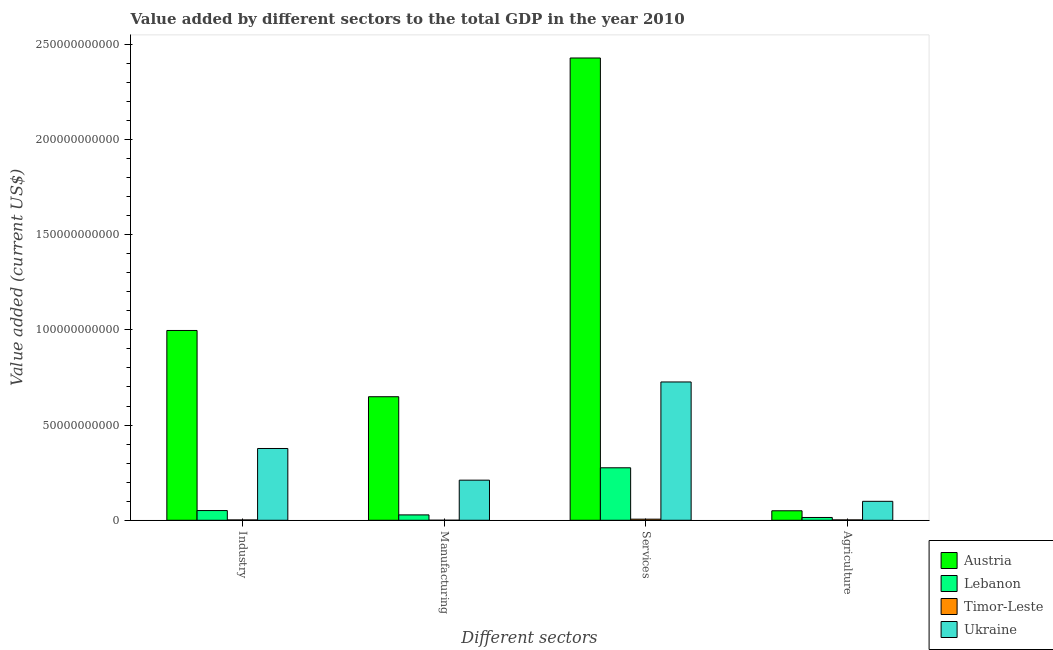How many different coloured bars are there?
Your response must be concise. 4. Are the number of bars per tick equal to the number of legend labels?
Offer a very short reply. Yes. How many bars are there on the 1st tick from the left?
Your answer should be compact. 4. What is the label of the 3rd group of bars from the left?
Keep it short and to the point. Services. Across all countries, what is the maximum value added by manufacturing sector?
Make the answer very short. 6.49e+1. Across all countries, what is the minimum value added by services sector?
Your answer should be compact. 5.83e+08. In which country was the value added by industrial sector maximum?
Keep it short and to the point. Austria. In which country was the value added by agricultural sector minimum?
Offer a very short reply. Timor-Leste. What is the total value added by manufacturing sector in the graph?
Keep it short and to the point. 8.88e+1. What is the difference between the value added by manufacturing sector in Ukraine and that in Lebanon?
Provide a succinct answer. 1.82e+1. What is the difference between the value added by manufacturing sector in Lebanon and the value added by industrial sector in Timor-Leste?
Offer a very short reply. 2.65e+09. What is the average value added by industrial sector per country?
Provide a succinct answer. 3.57e+1. What is the difference between the value added by manufacturing sector and value added by services sector in Timor-Leste?
Offer a very short reply. -5.73e+08. In how many countries, is the value added by agricultural sector greater than 150000000000 US$?
Keep it short and to the point. 0. What is the ratio of the value added by services sector in Timor-Leste to that in Lebanon?
Give a very brief answer. 0.02. Is the value added by agricultural sector in Ukraine less than that in Lebanon?
Provide a short and direct response. No. What is the difference between the highest and the second highest value added by agricultural sector?
Keep it short and to the point. 4.97e+09. What is the difference between the highest and the lowest value added by services sector?
Give a very brief answer. 2.42e+11. Is the sum of the value added by industrial sector in Ukraine and Lebanon greater than the maximum value added by manufacturing sector across all countries?
Offer a terse response. No. What does the 3rd bar from the left in Manufacturing represents?
Keep it short and to the point. Timor-Leste. What does the 3rd bar from the right in Manufacturing represents?
Make the answer very short. Lebanon. Is it the case that in every country, the sum of the value added by industrial sector and value added by manufacturing sector is greater than the value added by services sector?
Offer a terse response. No. Are all the bars in the graph horizontal?
Give a very brief answer. No. How many countries are there in the graph?
Provide a succinct answer. 4. Does the graph contain any zero values?
Provide a short and direct response. No. Does the graph contain grids?
Give a very brief answer. No. Where does the legend appear in the graph?
Provide a short and direct response. Bottom right. How many legend labels are there?
Provide a short and direct response. 4. How are the legend labels stacked?
Offer a very short reply. Vertical. What is the title of the graph?
Give a very brief answer. Value added by different sectors to the total GDP in the year 2010. What is the label or title of the X-axis?
Offer a very short reply. Different sectors. What is the label or title of the Y-axis?
Your answer should be very brief. Value added (current US$). What is the Value added (current US$) of Austria in Industry?
Provide a short and direct response. 9.97e+1. What is the Value added (current US$) in Lebanon in Industry?
Ensure brevity in your answer.  5.10e+09. What is the Value added (current US$) in Timor-Leste in Industry?
Provide a succinct answer. 1.66e+08. What is the Value added (current US$) of Ukraine in Industry?
Ensure brevity in your answer.  3.77e+1. What is the Value added (current US$) in Austria in Manufacturing?
Ensure brevity in your answer.  6.49e+1. What is the Value added (current US$) of Lebanon in Manufacturing?
Offer a very short reply. 2.82e+09. What is the Value added (current US$) in Timor-Leste in Manufacturing?
Provide a short and direct response. 1.00e+07. What is the Value added (current US$) in Ukraine in Manufacturing?
Your response must be concise. 2.11e+1. What is the Value added (current US$) in Austria in Services?
Your answer should be very brief. 2.43e+11. What is the Value added (current US$) in Lebanon in Services?
Ensure brevity in your answer.  2.76e+1. What is the Value added (current US$) of Timor-Leste in Services?
Provide a short and direct response. 5.83e+08. What is the Value added (current US$) of Ukraine in Services?
Keep it short and to the point. 7.26e+1. What is the Value added (current US$) in Austria in Agriculture?
Offer a terse response. 4.98e+09. What is the Value added (current US$) in Lebanon in Agriculture?
Ensure brevity in your answer.  1.46e+09. What is the Value added (current US$) in Timor-Leste in Agriculture?
Provide a succinct answer. 1.91e+08. What is the Value added (current US$) of Ukraine in Agriculture?
Keep it short and to the point. 9.95e+09. Across all Different sectors, what is the maximum Value added (current US$) of Austria?
Your answer should be very brief. 2.43e+11. Across all Different sectors, what is the maximum Value added (current US$) of Lebanon?
Keep it short and to the point. 2.76e+1. Across all Different sectors, what is the maximum Value added (current US$) of Timor-Leste?
Provide a succinct answer. 5.83e+08. Across all Different sectors, what is the maximum Value added (current US$) of Ukraine?
Your answer should be very brief. 7.26e+1. Across all Different sectors, what is the minimum Value added (current US$) in Austria?
Your answer should be very brief. 4.98e+09. Across all Different sectors, what is the minimum Value added (current US$) in Lebanon?
Your answer should be very brief. 1.46e+09. Across all Different sectors, what is the minimum Value added (current US$) of Timor-Leste?
Offer a terse response. 1.00e+07. Across all Different sectors, what is the minimum Value added (current US$) of Ukraine?
Give a very brief answer. 9.95e+09. What is the total Value added (current US$) of Austria in the graph?
Your answer should be compact. 4.12e+11. What is the total Value added (current US$) in Lebanon in the graph?
Your answer should be very brief. 3.69e+1. What is the total Value added (current US$) of Timor-Leste in the graph?
Your answer should be very brief. 9.50e+08. What is the total Value added (current US$) in Ukraine in the graph?
Your response must be concise. 1.41e+11. What is the difference between the Value added (current US$) in Austria in Industry and that in Manufacturing?
Offer a terse response. 3.48e+1. What is the difference between the Value added (current US$) of Lebanon in Industry and that in Manufacturing?
Provide a short and direct response. 2.28e+09. What is the difference between the Value added (current US$) of Timor-Leste in Industry and that in Manufacturing?
Offer a very short reply. 1.56e+08. What is the difference between the Value added (current US$) of Ukraine in Industry and that in Manufacturing?
Offer a very short reply. 1.66e+1. What is the difference between the Value added (current US$) in Austria in Industry and that in Services?
Ensure brevity in your answer.  -1.43e+11. What is the difference between the Value added (current US$) in Lebanon in Industry and that in Services?
Your answer should be very brief. -2.25e+1. What is the difference between the Value added (current US$) of Timor-Leste in Industry and that in Services?
Make the answer very short. -4.17e+08. What is the difference between the Value added (current US$) in Ukraine in Industry and that in Services?
Your answer should be very brief. -3.49e+1. What is the difference between the Value added (current US$) of Austria in Industry and that in Agriculture?
Provide a succinct answer. 9.47e+1. What is the difference between the Value added (current US$) of Lebanon in Industry and that in Agriculture?
Provide a succinct answer. 3.63e+09. What is the difference between the Value added (current US$) in Timor-Leste in Industry and that in Agriculture?
Your answer should be very brief. -2.50e+07. What is the difference between the Value added (current US$) of Ukraine in Industry and that in Agriculture?
Your answer should be very brief. 2.77e+1. What is the difference between the Value added (current US$) of Austria in Manufacturing and that in Services?
Make the answer very short. -1.78e+11. What is the difference between the Value added (current US$) of Lebanon in Manufacturing and that in Services?
Provide a succinct answer. -2.47e+1. What is the difference between the Value added (current US$) of Timor-Leste in Manufacturing and that in Services?
Provide a succinct answer. -5.73e+08. What is the difference between the Value added (current US$) in Ukraine in Manufacturing and that in Services?
Your answer should be compact. -5.16e+1. What is the difference between the Value added (current US$) of Austria in Manufacturing and that in Agriculture?
Make the answer very short. 5.99e+1. What is the difference between the Value added (current US$) of Lebanon in Manufacturing and that in Agriculture?
Offer a terse response. 1.36e+09. What is the difference between the Value added (current US$) of Timor-Leste in Manufacturing and that in Agriculture?
Ensure brevity in your answer.  -1.81e+08. What is the difference between the Value added (current US$) of Ukraine in Manufacturing and that in Agriculture?
Make the answer very short. 1.11e+1. What is the difference between the Value added (current US$) in Austria in Services and that in Agriculture?
Your response must be concise. 2.38e+11. What is the difference between the Value added (current US$) of Lebanon in Services and that in Agriculture?
Your response must be concise. 2.61e+1. What is the difference between the Value added (current US$) in Timor-Leste in Services and that in Agriculture?
Offer a terse response. 3.92e+08. What is the difference between the Value added (current US$) in Ukraine in Services and that in Agriculture?
Keep it short and to the point. 6.27e+1. What is the difference between the Value added (current US$) in Austria in Industry and the Value added (current US$) in Lebanon in Manufacturing?
Your response must be concise. 9.69e+1. What is the difference between the Value added (current US$) in Austria in Industry and the Value added (current US$) in Timor-Leste in Manufacturing?
Provide a short and direct response. 9.97e+1. What is the difference between the Value added (current US$) of Austria in Industry and the Value added (current US$) of Ukraine in Manufacturing?
Your answer should be very brief. 7.86e+1. What is the difference between the Value added (current US$) of Lebanon in Industry and the Value added (current US$) of Timor-Leste in Manufacturing?
Offer a very short reply. 5.09e+09. What is the difference between the Value added (current US$) in Lebanon in Industry and the Value added (current US$) in Ukraine in Manufacturing?
Provide a short and direct response. -1.60e+1. What is the difference between the Value added (current US$) in Timor-Leste in Industry and the Value added (current US$) in Ukraine in Manufacturing?
Your answer should be compact. -2.09e+1. What is the difference between the Value added (current US$) of Austria in Industry and the Value added (current US$) of Lebanon in Services?
Your response must be concise. 7.21e+1. What is the difference between the Value added (current US$) of Austria in Industry and the Value added (current US$) of Timor-Leste in Services?
Your answer should be very brief. 9.91e+1. What is the difference between the Value added (current US$) in Austria in Industry and the Value added (current US$) in Ukraine in Services?
Give a very brief answer. 2.70e+1. What is the difference between the Value added (current US$) in Lebanon in Industry and the Value added (current US$) in Timor-Leste in Services?
Provide a succinct answer. 4.51e+09. What is the difference between the Value added (current US$) of Lebanon in Industry and the Value added (current US$) of Ukraine in Services?
Make the answer very short. -6.75e+1. What is the difference between the Value added (current US$) of Timor-Leste in Industry and the Value added (current US$) of Ukraine in Services?
Your response must be concise. -7.25e+1. What is the difference between the Value added (current US$) of Austria in Industry and the Value added (current US$) of Lebanon in Agriculture?
Make the answer very short. 9.82e+1. What is the difference between the Value added (current US$) of Austria in Industry and the Value added (current US$) of Timor-Leste in Agriculture?
Make the answer very short. 9.95e+1. What is the difference between the Value added (current US$) in Austria in Industry and the Value added (current US$) in Ukraine in Agriculture?
Ensure brevity in your answer.  8.97e+1. What is the difference between the Value added (current US$) of Lebanon in Industry and the Value added (current US$) of Timor-Leste in Agriculture?
Your answer should be compact. 4.91e+09. What is the difference between the Value added (current US$) in Lebanon in Industry and the Value added (current US$) in Ukraine in Agriculture?
Your answer should be compact. -4.85e+09. What is the difference between the Value added (current US$) in Timor-Leste in Industry and the Value added (current US$) in Ukraine in Agriculture?
Make the answer very short. -9.78e+09. What is the difference between the Value added (current US$) in Austria in Manufacturing and the Value added (current US$) in Lebanon in Services?
Provide a short and direct response. 3.73e+1. What is the difference between the Value added (current US$) in Austria in Manufacturing and the Value added (current US$) in Timor-Leste in Services?
Your answer should be very brief. 6.43e+1. What is the difference between the Value added (current US$) in Austria in Manufacturing and the Value added (current US$) in Ukraine in Services?
Offer a terse response. -7.76e+09. What is the difference between the Value added (current US$) in Lebanon in Manufacturing and the Value added (current US$) in Timor-Leste in Services?
Your response must be concise. 2.24e+09. What is the difference between the Value added (current US$) of Lebanon in Manufacturing and the Value added (current US$) of Ukraine in Services?
Keep it short and to the point. -6.98e+1. What is the difference between the Value added (current US$) of Timor-Leste in Manufacturing and the Value added (current US$) of Ukraine in Services?
Keep it short and to the point. -7.26e+1. What is the difference between the Value added (current US$) in Austria in Manufacturing and the Value added (current US$) in Lebanon in Agriculture?
Your answer should be very brief. 6.34e+1. What is the difference between the Value added (current US$) in Austria in Manufacturing and the Value added (current US$) in Timor-Leste in Agriculture?
Your answer should be compact. 6.47e+1. What is the difference between the Value added (current US$) in Austria in Manufacturing and the Value added (current US$) in Ukraine in Agriculture?
Your answer should be very brief. 5.49e+1. What is the difference between the Value added (current US$) in Lebanon in Manufacturing and the Value added (current US$) in Timor-Leste in Agriculture?
Provide a succinct answer. 2.63e+09. What is the difference between the Value added (current US$) of Lebanon in Manufacturing and the Value added (current US$) of Ukraine in Agriculture?
Provide a succinct answer. -7.13e+09. What is the difference between the Value added (current US$) in Timor-Leste in Manufacturing and the Value added (current US$) in Ukraine in Agriculture?
Ensure brevity in your answer.  -9.94e+09. What is the difference between the Value added (current US$) in Austria in Services and the Value added (current US$) in Lebanon in Agriculture?
Your answer should be very brief. 2.41e+11. What is the difference between the Value added (current US$) of Austria in Services and the Value added (current US$) of Timor-Leste in Agriculture?
Keep it short and to the point. 2.43e+11. What is the difference between the Value added (current US$) in Austria in Services and the Value added (current US$) in Ukraine in Agriculture?
Your response must be concise. 2.33e+11. What is the difference between the Value added (current US$) in Lebanon in Services and the Value added (current US$) in Timor-Leste in Agriculture?
Your answer should be very brief. 2.74e+1. What is the difference between the Value added (current US$) in Lebanon in Services and the Value added (current US$) in Ukraine in Agriculture?
Give a very brief answer. 1.76e+1. What is the difference between the Value added (current US$) of Timor-Leste in Services and the Value added (current US$) of Ukraine in Agriculture?
Keep it short and to the point. -9.37e+09. What is the average Value added (current US$) in Austria per Different sectors?
Your answer should be compact. 1.03e+11. What is the average Value added (current US$) in Lebanon per Different sectors?
Offer a very short reply. 9.23e+09. What is the average Value added (current US$) in Timor-Leste per Different sectors?
Offer a terse response. 2.38e+08. What is the average Value added (current US$) of Ukraine per Different sectors?
Provide a short and direct response. 3.53e+1. What is the difference between the Value added (current US$) in Austria and Value added (current US$) in Lebanon in Industry?
Your response must be concise. 9.46e+1. What is the difference between the Value added (current US$) of Austria and Value added (current US$) of Timor-Leste in Industry?
Ensure brevity in your answer.  9.95e+1. What is the difference between the Value added (current US$) in Austria and Value added (current US$) in Ukraine in Industry?
Provide a succinct answer. 6.20e+1. What is the difference between the Value added (current US$) of Lebanon and Value added (current US$) of Timor-Leste in Industry?
Provide a succinct answer. 4.93e+09. What is the difference between the Value added (current US$) of Lebanon and Value added (current US$) of Ukraine in Industry?
Your response must be concise. -3.26e+1. What is the difference between the Value added (current US$) in Timor-Leste and Value added (current US$) in Ukraine in Industry?
Give a very brief answer. -3.75e+1. What is the difference between the Value added (current US$) in Austria and Value added (current US$) in Lebanon in Manufacturing?
Keep it short and to the point. 6.21e+1. What is the difference between the Value added (current US$) in Austria and Value added (current US$) in Timor-Leste in Manufacturing?
Keep it short and to the point. 6.49e+1. What is the difference between the Value added (current US$) in Austria and Value added (current US$) in Ukraine in Manufacturing?
Offer a terse response. 4.38e+1. What is the difference between the Value added (current US$) in Lebanon and Value added (current US$) in Timor-Leste in Manufacturing?
Your answer should be compact. 2.81e+09. What is the difference between the Value added (current US$) of Lebanon and Value added (current US$) of Ukraine in Manufacturing?
Provide a short and direct response. -1.82e+1. What is the difference between the Value added (current US$) of Timor-Leste and Value added (current US$) of Ukraine in Manufacturing?
Offer a very short reply. -2.11e+1. What is the difference between the Value added (current US$) in Austria and Value added (current US$) in Lebanon in Services?
Your response must be concise. 2.15e+11. What is the difference between the Value added (current US$) of Austria and Value added (current US$) of Timor-Leste in Services?
Give a very brief answer. 2.42e+11. What is the difference between the Value added (current US$) in Austria and Value added (current US$) in Ukraine in Services?
Make the answer very short. 1.70e+11. What is the difference between the Value added (current US$) in Lebanon and Value added (current US$) in Timor-Leste in Services?
Provide a short and direct response. 2.70e+1. What is the difference between the Value added (current US$) in Lebanon and Value added (current US$) in Ukraine in Services?
Your response must be concise. -4.51e+1. What is the difference between the Value added (current US$) of Timor-Leste and Value added (current US$) of Ukraine in Services?
Your response must be concise. -7.21e+1. What is the difference between the Value added (current US$) of Austria and Value added (current US$) of Lebanon in Agriculture?
Offer a very short reply. 3.52e+09. What is the difference between the Value added (current US$) of Austria and Value added (current US$) of Timor-Leste in Agriculture?
Make the answer very short. 4.79e+09. What is the difference between the Value added (current US$) of Austria and Value added (current US$) of Ukraine in Agriculture?
Offer a terse response. -4.97e+09. What is the difference between the Value added (current US$) in Lebanon and Value added (current US$) in Timor-Leste in Agriculture?
Provide a succinct answer. 1.27e+09. What is the difference between the Value added (current US$) in Lebanon and Value added (current US$) in Ukraine in Agriculture?
Provide a succinct answer. -8.49e+09. What is the difference between the Value added (current US$) of Timor-Leste and Value added (current US$) of Ukraine in Agriculture?
Your answer should be very brief. -9.76e+09. What is the ratio of the Value added (current US$) in Austria in Industry to that in Manufacturing?
Provide a short and direct response. 1.54. What is the ratio of the Value added (current US$) of Lebanon in Industry to that in Manufacturing?
Your answer should be compact. 1.81. What is the ratio of the Value added (current US$) of Timor-Leste in Industry to that in Manufacturing?
Make the answer very short. 16.6. What is the ratio of the Value added (current US$) in Ukraine in Industry to that in Manufacturing?
Offer a very short reply. 1.79. What is the ratio of the Value added (current US$) of Austria in Industry to that in Services?
Give a very brief answer. 0.41. What is the ratio of the Value added (current US$) of Lebanon in Industry to that in Services?
Offer a terse response. 0.18. What is the ratio of the Value added (current US$) in Timor-Leste in Industry to that in Services?
Offer a terse response. 0.28. What is the ratio of the Value added (current US$) in Ukraine in Industry to that in Services?
Provide a short and direct response. 0.52. What is the ratio of the Value added (current US$) of Austria in Industry to that in Agriculture?
Ensure brevity in your answer.  20. What is the ratio of the Value added (current US$) of Lebanon in Industry to that in Agriculture?
Offer a very short reply. 3.48. What is the ratio of the Value added (current US$) in Timor-Leste in Industry to that in Agriculture?
Your answer should be very brief. 0.87. What is the ratio of the Value added (current US$) in Ukraine in Industry to that in Agriculture?
Provide a succinct answer. 3.79. What is the ratio of the Value added (current US$) of Austria in Manufacturing to that in Services?
Your response must be concise. 0.27. What is the ratio of the Value added (current US$) of Lebanon in Manufacturing to that in Services?
Your answer should be very brief. 0.1. What is the ratio of the Value added (current US$) in Timor-Leste in Manufacturing to that in Services?
Your response must be concise. 0.02. What is the ratio of the Value added (current US$) in Ukraine in Manufacturing to that in Services?
Make the answer very short. 0.29. What is the ratio of the Value added (current US$) in Austria in Manufacturing to that in Agriculture?
Give a very brief answer. 13.02. What is the ratio of the Value added (current US$) of Lebanon in Manufacturing to that in Agriculture?
Your answer should be very brief. 1.93. What is the ratio of the Value added (current US$) of Timor-Leste in Manufacturing to that in Agriculture?
Make the answer very short. 0.05. What is the ratio of the Value added (current US$) of Ukraine in Manufacturing to that in Agriculture?
Offer a very short reply. 2.12. What is the ratio of the Value added (current US$) in Austria in Services to that in Agriculture?
Offer a very short reply. 48.72. What is the ratio of the Value added (current US$) of Lebanon in Services to that in Agriculture?
Offer a very short reply. 18.84. What is the ratio of the Value added (current US$) in Timor-Leste in Services to that in Agriculture?
Ensure brevity in your answer.  3.05. What is the ratio of the Value added (current US$) of Ukraine in Services to that in Agriculture?
Make the answer very short. 7.3. What is the difference between the highest and the second highest Value added (current US$) of Austria?
Make the answer very short. 1.43e+11. What is the difference between the highest and the second highest Value added (current US$) in Lebanon?
Make the answer very short. 2.25e+1. What is the difference between the highest and the second highest Value added (current US$) of Timor-Leste?
Offer a very short reply. 3.92e+08. What is the difference between the highest and the second highest Value added (current US$) of Ukraine?
Make the answer very short. 3.49e+1. What is the difference between the highest and the lowest Value added (current US$) of Austria?
Keep it short and to the point. 2.38e+11. What is the difference between the highest and the lowest Value added (current US$) in Lebanon?
Offer a very short reply. 2.61e+1. What is the difference between the highest and the lowest Value added (current US$) in Timor-Leste?
Provide a short and direct response. 5.73e+08. What is the difference between the highest and the lowest Value added (current US$) in Ukraine?
Ensure brevity in your answer.  6.27e+1. 